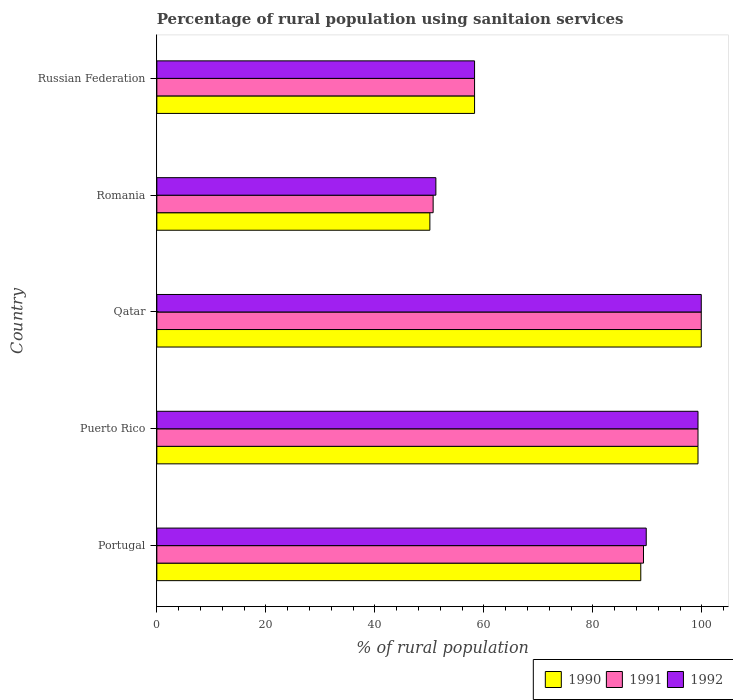How many different coloured bars are there?
Provide a short and direct response. 3. Are the number of bars on each tick of the Y-axis equal?
Your answer should be compact. Yes. How many bars are there on the 3rd tick from the top?
Provide a succinct answer. 3. How many bars are there on the 5th tick from the bottom?
Provide a succinct answer. 3. What is the label of the 1st group of bars from the top?
Provide a short and direct response. Russian Federation. In how many cases, is the number of bars for a given country not equal to the number of legend labels?
Your answer should be very brief. 0. What is the percentage of rural population using sanitaion services in 1990 in Qatar?
Keep it short and to the point. 99.9. Across all countries, what is the maximum percentage of rural population using sanitaion services in 1991?
Provide a succinct answer. 99.9. Across all countries, what is the minimum percentage of rural population using sanitaion services in 1991?
Your answer should be compact. 50.7. In which country was the percentage of rural population using sanitaion services in 1991 maximum?
Provide a short and direct response. Qatar. In which country was the percentage of rural population using sanitaion services in 1991 minimum?
Make the answer very short. Romania. What is the total percentage of rural population using sanitaion services in 1991 in the graph?
Offer a terse response. 397.5. What is the difference between the percentage of rural population using sanitaion services in 1992 in Portugal and that in Qatar?
Your response must be concise. -10.1. What is the difference between the percentage of rural population using sanitaion services in 1992 in Russian Federation and the percentage of rural population using sanitaion services in 1991 in Portugal?
Offer a terse response. -31. What is the average percentage of rural population using sanitaion services in 1992 per country?
Your answer should be very brief. 79.7. In how many countries, is the percentage of rural population using sanitaion services in 1991 greater than 8 %?
Keep it short and to the point. 5. What is the ratio of the percentage of rural population using sanitaion services in 1992 in Puerto Rico to that in Romania?
Ensure brevity in your answer.  1.94. What is the difference between the highest and the second highest percentage of rural population using sanitaion services in 1990?
Give a very brief answer. 0.6. What is the difference between the highest and the lowest percentage of rural population using sanitaion services in 1991?
Offer a very short reply. 49.2. Is the sum of the percentage of rural population using sanitaion services in 1992 in Portugal and Puerto Rico greater than the maximum percentage of rural population using sanitaion services in 1990 across all countries?
Your answer should be very brief. Yes. What does the 1st bar from the top in Qatar represents?
Ensure brevity in your answer.  1992. Is it the case that in every country, the sum of the percentage of rural population using sanitaion services in 1992 and percentage of rural population using sanitaion services in 1991 is greater than the percentage of rural population using sanitaion services in 1990?
Your response must be concise. Yes. Are all the bars in the graph horizontal?
Ensure brevity in your answer.  Yes. Where does the legend appear in the graph?
Keep it short and to the point. Bottom right. How are the legend labels stacked?
Give a very brief answer. Horizontal. What is the title of the graph?
Provide a short and direct response. Percentage of rural population using sanitaion services. What is the label or title of the X-axis?
Your response must be concise. % of rural population. What is the % of rural population of 1990 in Portugal?
Keep it short and to the point. 88.8. What is the % of rural population in 1991 in Portugal?
Your response must be concise. 89.3. What is the % of rural population of 1992 in Portugal?
Your answer should be very brief. 89.8. What is the % of rural population of 1990 in Puerto Rico?
Offer a terse response. 99.3. What is the % of rural population of 1991 in Puerto Rico?
Offer a terse response. 99.3. What is the % of rural population of 1992 in Puerto Rico?
Provide a succinct answer. 99.3. What is the % of rural population of 1990 in Qatar?
Give a very brief answer. 99.9. What is the % of rural population in 1991 in Qatar?
Offer a terse response. 99.9. What is the % of rural population in 1992 in Qatar?
Your response must be concise. 99.9. What is the % of rural population of 1990 in Romania?
Provide a short and direct response. 50.1. What is the % of rural population in 1991 in Romania?
Offer a terse response. 50.7. What is the % of rural population of 1992 in Romania?
Your response must be concise. 51.2. What is the % of rural population of 1990 in Russian Federation?
Your response must be concise. 58.3. What is the % of rural population of 1991 in Russian Federation?
Your answer should be compact. 58.3. What is the % of rural population of 1992 in Russian Federation?
Give a very brief answer. 58.3. Across all countries, what is the maximum % of rural population in 1990?
Your answer should be very brief. 99.9. Across all countries, what is the maximum % of rural population of 1991?
Provide a succinct answer. 99.9. Across all countries, what is the maximum % of rural population in 1992?
Ensure brevity in your answer.  99.9. Across all countries, what is the minimum % of rural population of 1990?
Offer a terse response. 50.1. Across all countries, what is the minimum % of rural population of 1991?
Provide a succinct answer. 50.7. Across all countries, what is the minimum % of rural population in 1992?
Provide a succinct answer. 51.2. What is the total % of rural population in 1990 in the graph?
Offer a very short reply. 396.4. What is the total % of rural population in 1991 in the graph?
Ensure brevity in your answer.  397.5. What is the total % of rural population in 1992 in the graph?
Provide a succinct answer. 398.5. What is the difference between the % of rural population in 1990 in Portugal and that in Puerto Rico?
Offer a terse response. -10.5. What is the difference between the % of rural population of 1991 in Portugal and that in Puerto Rico?
Keep it short and to the point. -10. What is the difference between the % of rural population of 1992 in Portugal and that in Puerto Rico?
Offer a terse response. -9.5. What is the difference between the % of rural population in 1991 in Portugal and that in Qatar?
Provide a short and direct response. -10.6. What is the difference between the % of rural population of 1990 in Portugal and that in Romania?
Provide a succinct answer. 38.7. What is the difference between the % of rural population in 1991 in Portugal and that in Romania?
Your response must be concise. 38.6. What is the difference between the % of rural population in 1992 in Portugal and that in Romania?
Provide a succinct answer. 38.6. What is the difference between the % of rural population of 1990 in Portugal and that in Russian Federation?
Offer a very short reply. 30.5. What is the difference between the % of rural population in 1992 in Portugal and that in Russian Federation?
Keep it short and to the point. 31.5. What is the difference between the % of rural population in 1990 in Puerto Rico and that in Qatar?
Offer a very short reply. -0.6. What is the difference between the % of rural population of 1991 in Puerto Rico and that in Qatar?
Make the answer very short. -0.6. What is the difference between the % of rural population of 1992 in Puerto Rico and that in Qatar?
Offer a very short reply. -0.6. What is the difference between the % of rural population of 1990 in Puerto Rico and that in Romania?
Make the answer very short. 49.2. What is the difference between the % of rural population of 1991 in Puerto Rico and that in Romania?
Your answer should be very brief. 48.6. What is the difference between the % of rural population in 1992 in Puerto Rico and that in Romania?
Your response must be concise. 48.1. What is the difference between the % of rural population of 1991 in Puerto Rico and that in Russian Federation?
Your answer should be compact. 41. What is the difference between the % of rural population in 1990 in Qatar and that in Romania?
Your response must be concise. 49.8. What is the difference between the % of rural population of 1991 in Qatar and that in Romania?
Offer a very short reply. 49.2. What is the difference between the % of rural population in 1992 in Qatar and that in Romania?
Give a very brief answer. 48.7. What is the difference between the % of rural population in 1990 in Qatar and that in Russian Federation?
Your answer should be compact. 41.6. What is the difference between the % of rural population in 1991 in Qatar and that in Russian Federation?
Make the answer very short. 41.6. What is the difference between the % of rural population of 1992 in Qatar and that in Russian Federation?
Your answer should be very brief. 41.6. What is the difference between the % of rural population in 1991 in Romania and that in Russian Federation?
Provide a succinct answer. -7.6. What is the difference between the % of rural population of 1992 in Romania and that in Russian Federation?
Provide a short and direct response. -7.1. What is the difference between the % of rural population in 1990 in Portugal and the % of rural population in 1992 in Qatar?
Your answer should be compact. -11.1. What is the difference between the % of rural population of 1990 in Portugal and the % of rural population of 1991 in Romania?
Offer a terse response. 38.1. What is the difference between the % of rural population in 1990 in Portugal and the % of rural population in 1992 in Romania?
Your answer should be very brief. 37.6. What is the difference between the % of rural population of 1991 in Portugal and the % of rural population of 1992 in Romania?
Keep it short and to the point. 38.1. What is the difference between the % of rural population in 1990 in Portugal and the % of rural population in 1991 in Russian Federation?
Your answer should be compact. 30.5. What is the difference between the % of rural population in 1990 in Portugal and the % of rural population in 1992 in Russian Federation?
Your answer should be compact. 30.5. What is the difference between the % of rural population of 1990 in Puerto Rico and the % of rural population of 1992 in Qatar?
Offer a terse response. -0.6. What is the difference between the % of rural population of 1991 in Puerto Rico and the % of rural population of 1992 in Qatar?
Offer a very short reply. -0.6. What is the difference between the % of rural population in 1990 in Puerto Rico and the % of rural population in 1991 in Romania?
Offer a terse response. 48.6. What is the difference between the % of rural population in 1990 in Puerto Rico and the % of rural population in 1992 in Romania?
Provide a short and direct response. 48.1. What is the difference between the % of rural population in 1991 in Puerto Rico and the % of rural population in 1992 in Romania?
Provide a short and direct response. 48.1. What is the difference between the % of rural population of 1990 in Puerto Rico and the % of rural population of 1991 in Russian Federation?
Provide a short and direct response. 41. What is the difference between the % of rural population in 1990 in Puerto Rico and the % of rural population in 1992 in Russian Federation?
Offer a terse response. 41. What is the difference between the % of rural population in 1990 in Qatar and the % of rural population in 1991 in Romania?
Your answer should be compact. 49.2. What is the difference between the % of rural population of 1990 in Qatar and the % of rural population of 1992 in Romania?
Your response must be concise. 48.7. What is the difference between the % of rural population in 1991 in Qatar and the % of rural population in 1992 in Romania?
Ensure brevity in your answer.  48.7. What is the difference between the % of rural population in 1990 in Qatar and the % of rural population in 1991 in Russian Federation?
Provide a succinct answer. 41.6. What is the difference between the % of rural population in 1990 in Qatar and the % of rural population in 1992 in Russian Federation?
Ensure brevity in your answer.  41.6. What is the difference between the % of rural population of 1991 in Qatar and the % of rural population of 1992 in Russian Federation?
Offer a terse response. 41.6. What is the difference between the % of rural population in 1990 in Romania and the % of rural population in 1991 in Russian Federation?
Give a very brief answer. -8.2. What is the difference between the % of rural population in 1991 in Romania and the % of rural population in 1992 in Russian Federation?
Keep it short and to the point. -7.6. What is the average % of rural population of 1990 per country?
Ensure brevity in your answer.  79.28. What is the average % of rural population in 1991 per country?
Make the answer very short. 79.5. What is the average % of rural population in 1992 per country?
Offer a very short reply. 79.7. What is the difference between the % of rural population in 1990 and % of rural population in 1991 in Portugal?
Provide a short and direct response. -0.5. What is the difference between the % of rural population of 1990 and % of rural population of 1991 in Puerto Rico?
Your response must be concise. 0. What is the difference between the % of rural population of 1991 and % of rural population of 1992 in Puerto Rico?
Keep it short and to the point. 0. What is the difference between the % of rural population in 1990 and % of rural population in 1991 in Qatar?
Offer a terse response. 0. What is the difference between the % of rural population of 1990 and % of rural population of 1991 in Romania?
Your response must be concise. -0.6. What is the difference between the % of rural population in 1990 and % of rural population in 1992 in Romania?
Give a very brief answer. -1.1. What is the difference between the % of rural population of 1991 and % of rural population of 1992 in Romania?
Offer a terse response. -0.5. What is the difference between the % of rural population of 1990 and % of rural population of 1992 in Russian Federation?
Offer a very short reply. 0. What is the difference between the % of rural population in 1991 and % of rural population in 1992 in Russian Federation?
Your answer should be compact. 0. What is the ratio of the % of rural population of 1990 in Portugal to that in Puerto Rico?
Keep it short and to the point. 0.89. What is the ratio of the % of rural population of 1991 in Portugal to that in Puerto Rico?
Keep it short and to the point. 0.9. What is the ratio of the % of rural population of 1992 in Portugal to that in Puerto Rico?
Your response must be concise. 0.9. What is the ratio of the % of rural population of 1991 in Portugal to that in Qatar?
Your response must be concise. 0.89. What is the ratio of the % of rural population of 1992 in Portugal to that in Qatar?
Your answer should be compact. 0.9. What is the ratio of the % of rural population in 1990 in Portugal to that in Romania?
Give a very brief answer. 1.77. What is the ratio of the % of rural population of 1991 in Portugal to that in Romania?
Offer a terse response. 1.76. What is the ratio of the % of rural population in 1992 in Portugal to that in Romania?
Provide a short and direct response. 1.75. What is the ratio of the % of rural population of 1990 in Portugal to that in Russian Federation?
Offer a very short reply. 1.52. What is the ratio of the % of rural population in 1991 in Portugal to that in Russian Federation?
Your answer should be compact. 1.53. What is the ratio of the % of rural population in 1992 in Portugal to that in Russian Federation?
Offer a terse response. 1.54. What is the ratio of the % of rural population of 1990 in Puerto Rico to that in Qatar?
Make the answer very short. 0.99. What is the ratio of the % of rural population of 1990 in Puerto Rico to that in Romania?
Your response must be concise. 1.98. What is the ratio of the % of rural population of 1991 in Puerto Rico to that in Romania?
Offer a very short reply. 1.96. What is the ratio of the % of rural population in 1992 in Puerto Rico to that in Romania?
Make the answer very short. 1.94. What is the ratio of the % of rural population in 1990 in Puerto Rico to that in Russian Federation?
Offer a very short reply. 1.7. What is the ratio of the % of rural population in 1991 in Puerto Rico to that in Russian Federation?
Make the answer very short. 1.7. What is the ratio of the % of rural population of 1992 in Puerto Rico to that in Russian Federation?
Your answer should be compact. 1.7. What is the ratio of the % of rural population of 1990 in Qatar to that in Romania?
Give a very brief answer. 1.99. What is the ratio of the % of rural population of 1991 in Qatar to that in Romania?
Make the answer very short. 1.97. What is the ratio of the % of rural population in 1992 in Qatar to that in Romania?
Ensure brevity in your answer.  1.95. What is the ratio of the % of rural population of 1990 in Qatar to that in Russian Federation?
Your answer should be compact. 1.71. What is the ratio of the % of rural population in 1991 in Qatar to that in Russian Federation?
Provide a succinct answer. 1.71. What is the ratio of the % of rural population in 1992 in Qatar to that in Russian Federation?
Provide a short and direct response. 1.71. What is the ratio of the % of rural population of 1990 in Romania to that in Russian Federation?
Give a very brief answer. 0.86. What is the ratio of the % of rural population in 1991 in Romania to that in Russian Federation?
Your answer should be compact. 0.87. What is the ratio of the % of rural population in 1992 in Romania to that in Russian Federation?
Give a very brief answer. 0.88. What is the difference between the highest and the second highest % of rural population of 1990?
Your answer should be compact. 0.6. What is the difference between the highest and the second highest % of rural population of 1991?
Provide a succinct answer. 0.6. What is the difference between the highest and the lowest % of rural population of 1990?
Offer a very short reply. 49.8. What is the difference between the highest and the lowest % of rural population of 1991?
Offer a terse response. 49.2. What is the difference between the highest and the lowest % of rural population of 1992?
Provide a short and direct response. 48.7. 